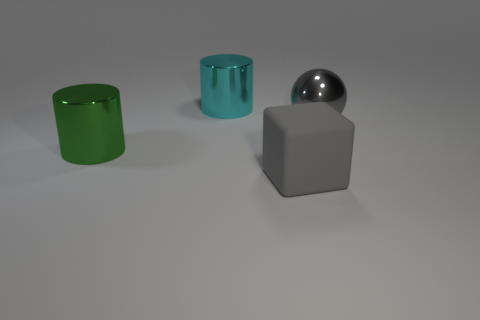Add 4 big yellow metallic cubes. How many objects exist? 8 Subtract all balls. How many objects are left? 3 Add 2 big cyan cylinders. How many big cyan cylinders exist? 3 Subtract 0 green blocks. How many objects are left? 4 Subtract all red rubber things. Subtract all metal objects. How many objects are left? 1 Add 2 large gray rubber objects. How many large gray rubber objects are left? 3 